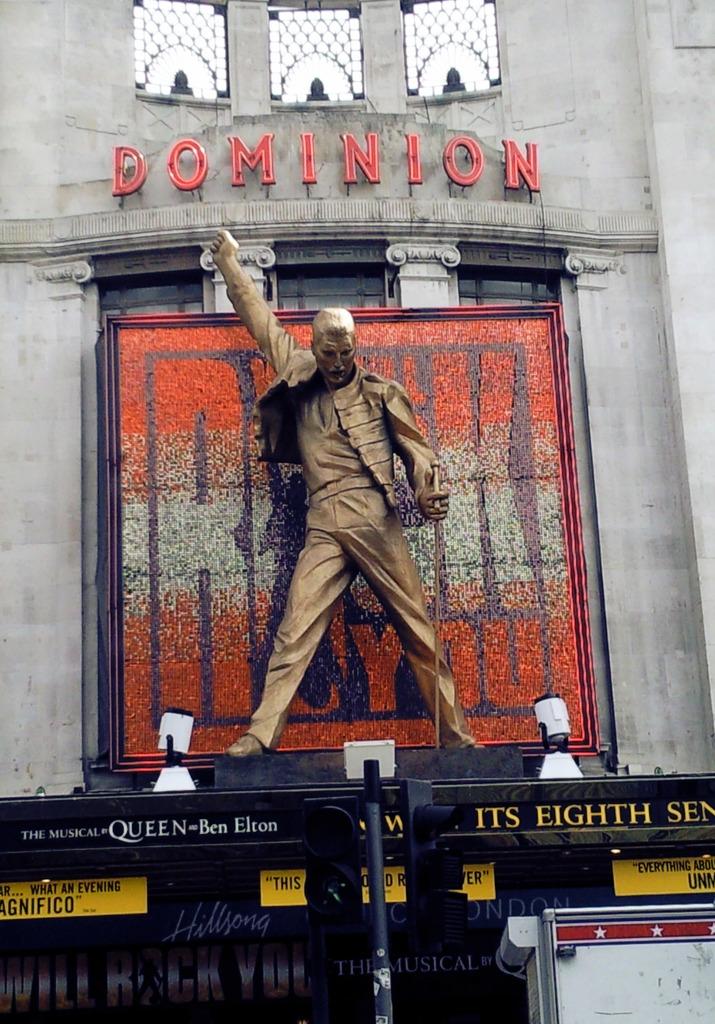What´s the name of the place?
Your answer should be very brief. Dominion. 